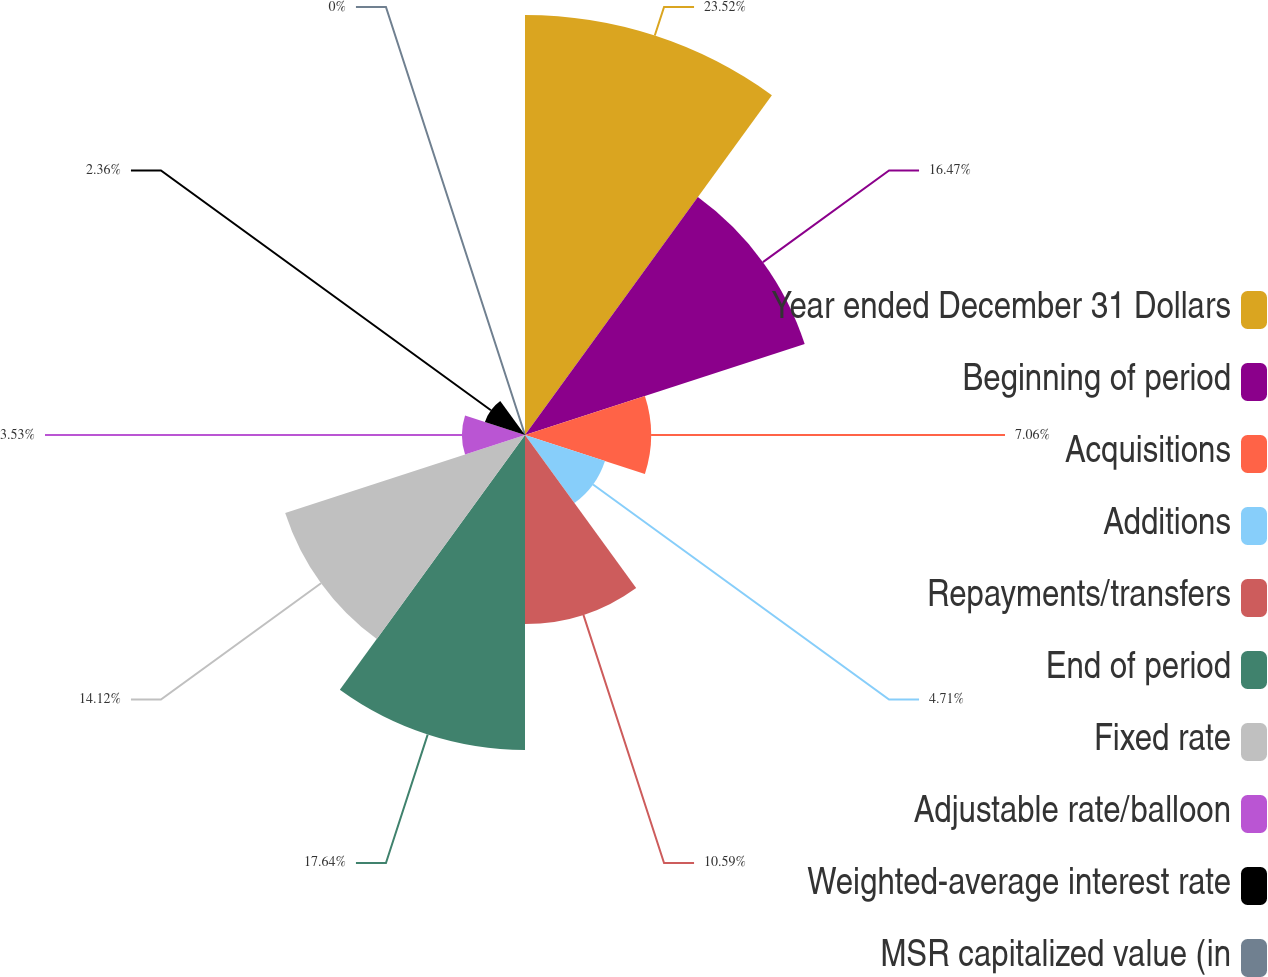<chart> <loc_0><loc_0><loc_500><loc_500><pie_chart><fcel>Year ended December 31 Dollars<fcel>Beginning of period<fcel>Acquisitions<fcel>Additions<fcel>Repayments/transfers<fcel>End of period<fcel>Fixed rate<fcel>Adjustable rate/balloon<fcel>Weighted-average interest rate<fcel>MSR capitalized value (in<nl><fcel>23.52%<fcel>16.47%<fcel>7.06%<fcel>4.71%<fcel>10.59%<fcel>17.64%<fcel>14.12%<fcel>3.53%<fcel>2.36%<fcel>0.0%<nl></chart> 